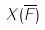Convert formula to latex. <formula><loc_0><loc_0><loc_500><loc_500>X ( \overline { F } )</formula> 